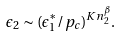<formula> <loc_0><loc_0><loc_500><loc_500>\epsilon _ { 2 } \sim ( \epsilon _ { 1 } ^ { \ast } / p _ { c } ) ^ { K n _ { 2 } ^ { \beta } } .</formula> 